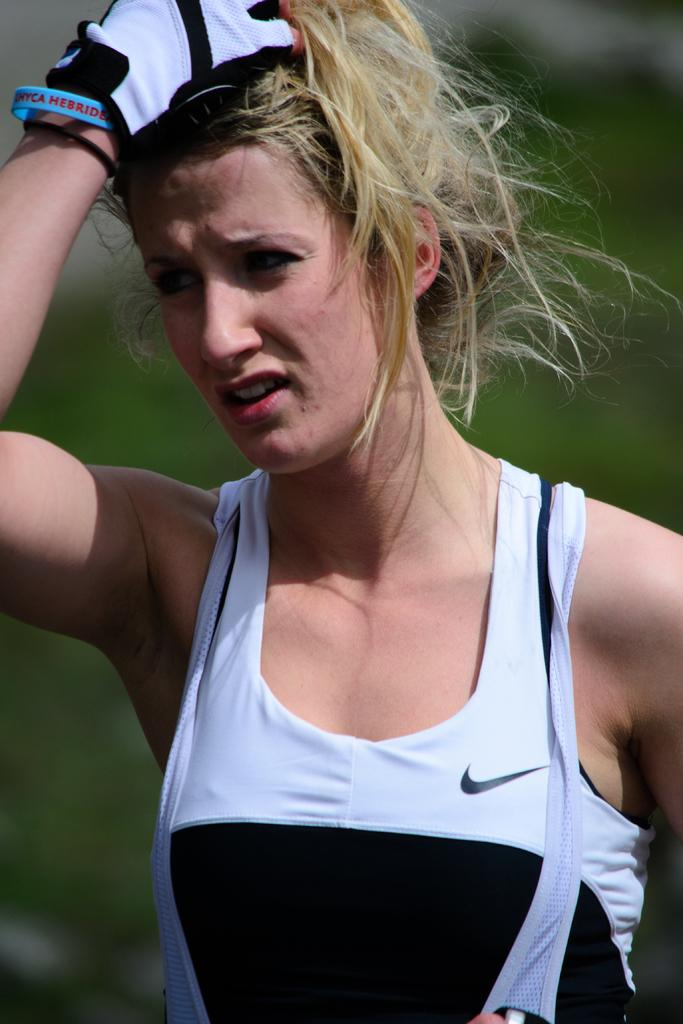What is the main subject of the image? The main subject of the image is a woman. Can you describe what the woman is wearing? The woman is wearing a white and black top. Is there a window in the image that the woman is looking out of? There is no window present in the image. 